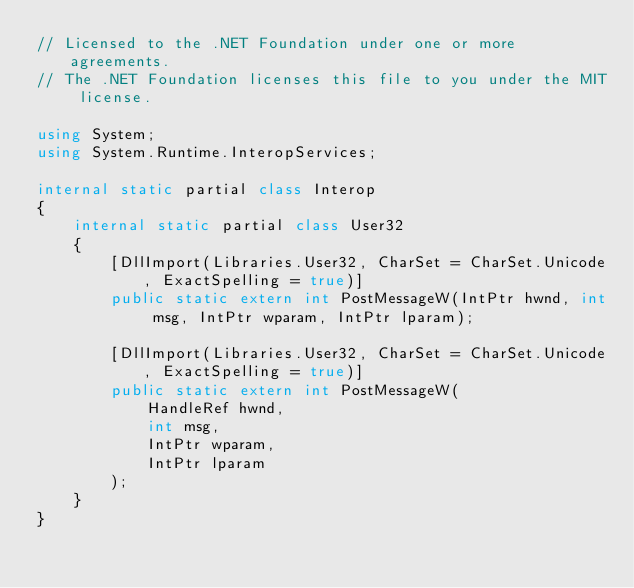<code> <loc_0><loc_0><loc_500><loc_500><_C#_>// Licensed to the .NET Foundation under one or more agreements.
// The .NET Foundation licenses this file to you under the MIT license.

using System;
using System.Runtime.InteropServices;

internal static partial class Interop
{
    internal static partial class User32
    {
        [DllImport(Libraries.User32, CharSet = CharSet.Unicode, ExactSpelling = true)]
        public static extern int PostMessageW(IntPtr hwnd, int msg, IntPtr wparam, IntPtr lparam);

        [DllImport(Libraries.User32, CharSet = CharSet.Unicode, ExactSpelling = true)]
        public static extern int PostMessageW(
            HandleRef hwnd,
            int msg,
            IntPtr wparam,
            IntPtr lparam
        );
    }
}
</code> 